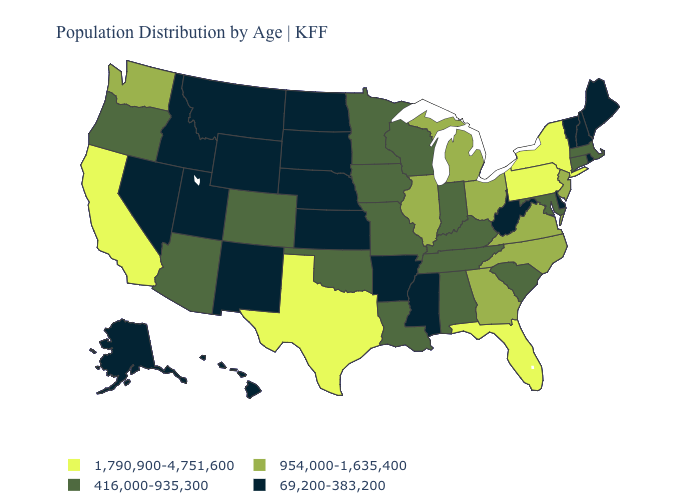What is the highest value in the USA?
Answer briefly. 1,790,900-4,751,600. Name the states that have a value in the range 69,200-383,200?
Quick response, please. Alaska, Arkansas, Delaware, Hawaii, Idaho, Kansas, Maine, Mississippi, Montana, Nebraska, Nevada, New Hampshire, New Mexico, North Dakota, Rhode Island, South Dakota, Utah, Vermont, West Virginia, Wyoming. Does the first symbol in the legend represent the smallest category?
Concise answer only. No. Name the states that have a value in the range 1,790,900-4,751,600?
Answer briefly. California, Florida, New York, Pennsylvania, Texas. Name the states that have a value in the range 954,000-1,635,400?
Keep it brief. Georgia, Illinois, Michigan, New Jersey, North Carolina, Ohio, Virginia, Washington. Does Georgia have the lowest value in the South?
Answer briefly. No. Name the states that have a value in the range 954,000-1,635,400?
Concise answer only. Georgia, Illinois, Michigan, New Jersey, North Carolina, Ohio, Virginia, Washington. Does Illinois have a lower value than Florida?
Be succinct. Yes. What is the lowest value in states that border Ohio?
Concise answer only. 69,200-383,200. Does Connecticut have the lowest value in the Northeast?
Give a very brief answer. No. What is the value of Wisconsin?
Concise answer only. 416,000-935,300. Among the states that border Nebraska , does Missouri have the lowest value?
Answer briefly. No. Does Alaska have a lower value than New Hampshire?
Short answer required. No. Which states have the highest value in the USA?
Quick response, please. California, Florida, New York, Pennsylvania, Texas. Name the states that have a value in the range 954,000-1,635,400?
Keep it brief. Georgia, Illinois, Michigan, New Jersey, North Carolina, Ohio, Virginia, Washington. 